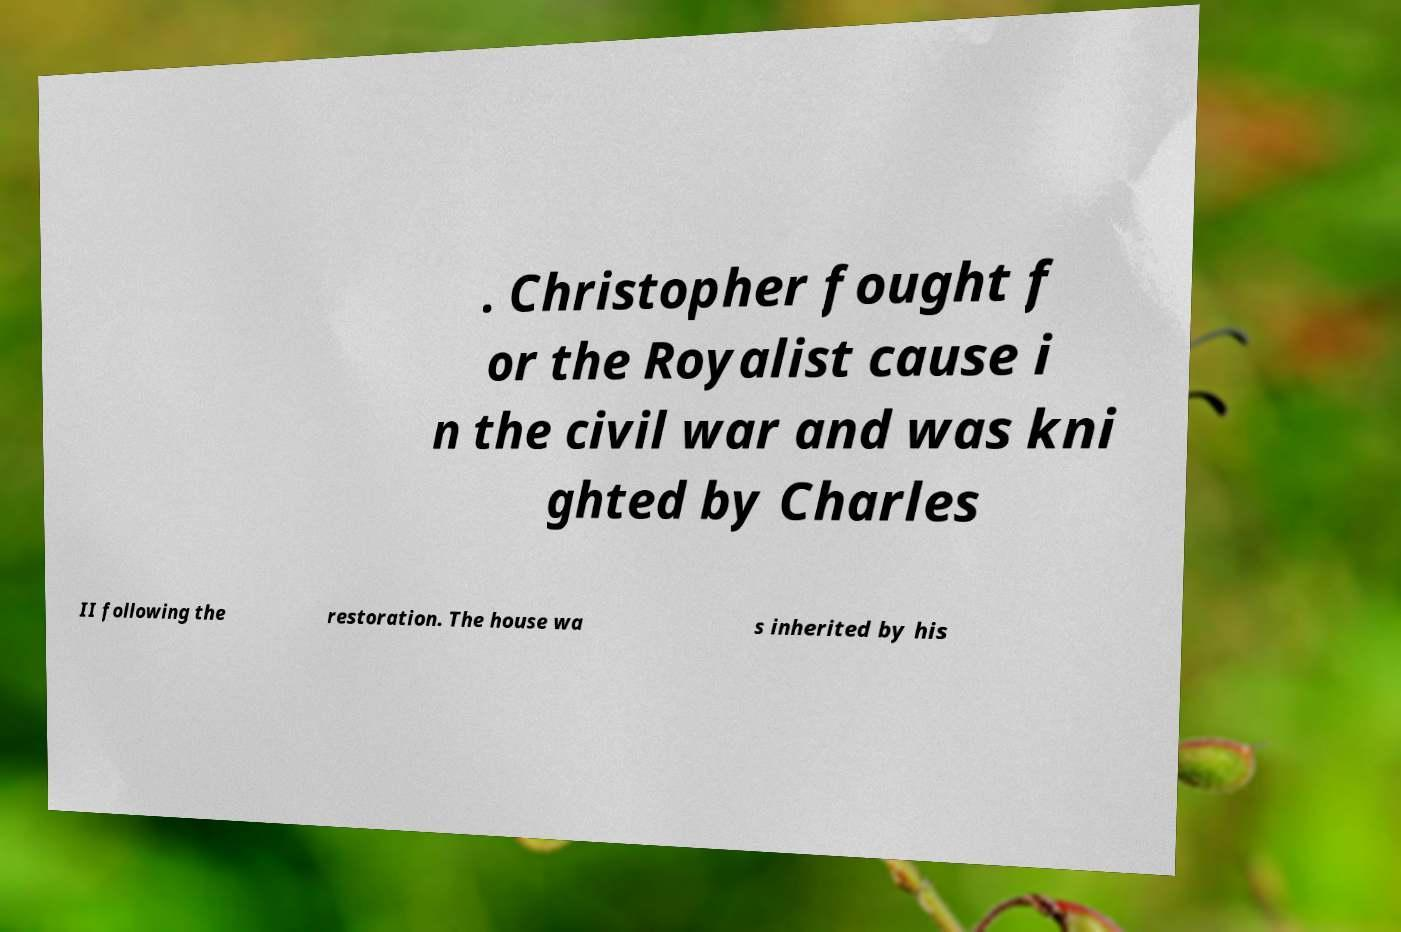Please identify and transcribe the text found in this image. . Christopher fought f or the Royalist cause i n the civil war and was kni ghted by Charles II following the restoration. The house wa s inherited by his 